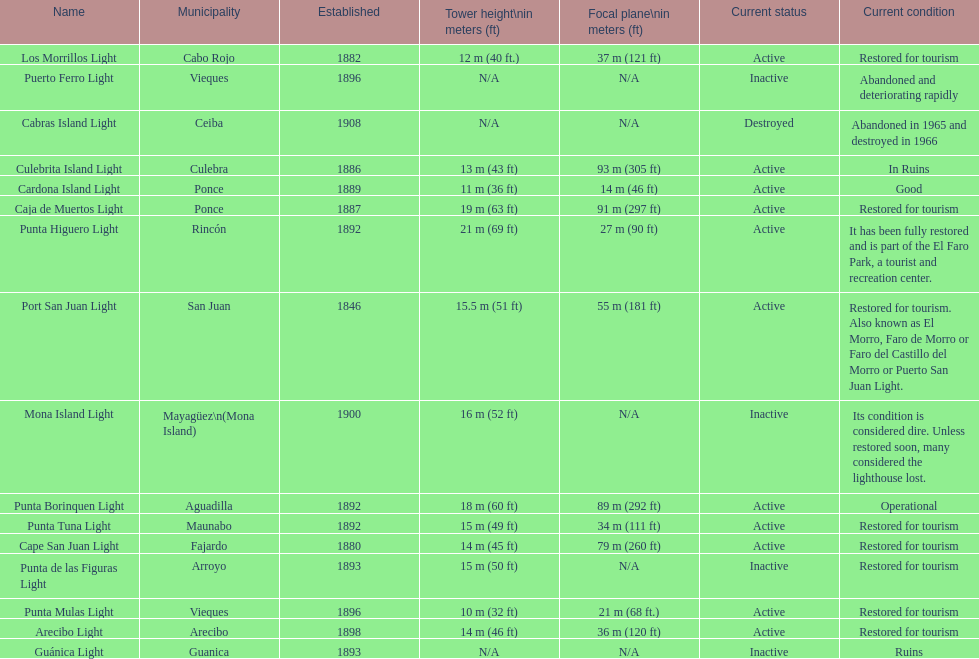Which municipality was the first to be established? San Juan. 